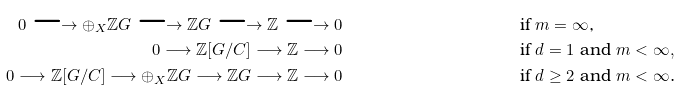Convert formula to latex. <formula><loc_0><loc_0><loc_500><loc_500>0 \longrightarrow \oplus _ { X } \mathbb { Z } G \longrightarrow \mathbb { Z } G \longrightarrow \mathbb { Z } \longrightarrow 0 & & & \text {if $m = \infty$,} \\ 0 \longrightarrow \mathbb { Z } [ G / C ] \longrightarrow \mathbb { Z } \longrightarrow 0 & & & \text {if $d = 1$ and $m < \infty,$} \\ 0 \longrightarrow \mathbb { Z } [ G / C ] \longrightarrow \oplus _ { X } \mathbb { Z } G \longrightarrow \mathbb { Z } G \longrightarrow \mathbb { Z } \longrightarrow 0 & & & \text {if $d \geq 2$ and $m < \infty$.}</formula> 